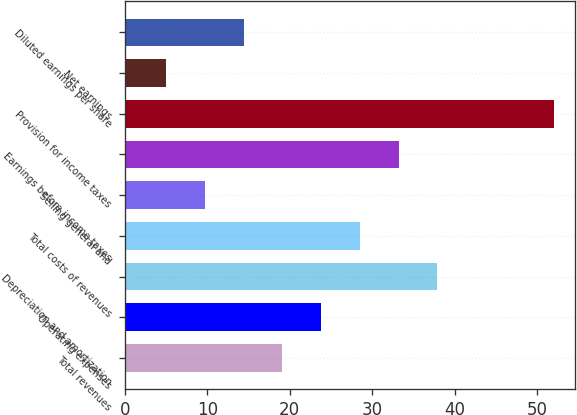<chart> <loc_0><loc_0><loc_500><loc_500><bar_chart><fcel>Total revenues<fcel>Operating expenses<fcel>Depreciation and amortization<fcel>Total costs of revenues<fcel>Selling general and<fcel>Earnings before income taxes<fcel>Provision for income taxes<fcel>Net earnings<fcel>Diluted earnings per share<nl><fcel>19.1<fcel>23.8<fcel>37.9<fcel>28.5<fcel>9.7<fcel>33.2<fcel>52<fcel>5<fcel>14.4<nl></chart> 